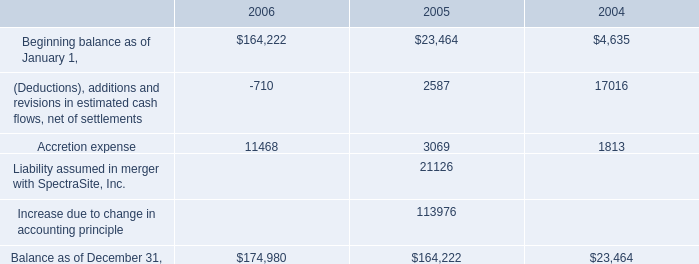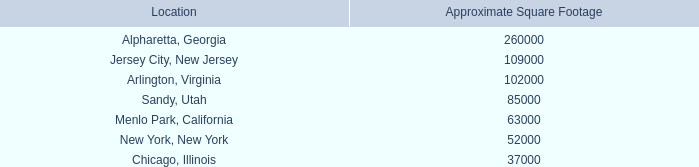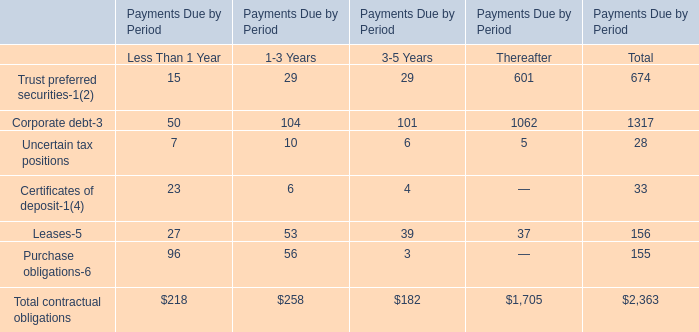What is the average amount of Sandy, Utah of Approximate Square Footage, and Balance as of December 31, of 2004 ? 
Computations: ((85000.0 + 23464.0) / 2)
Answer: 54232.0. 